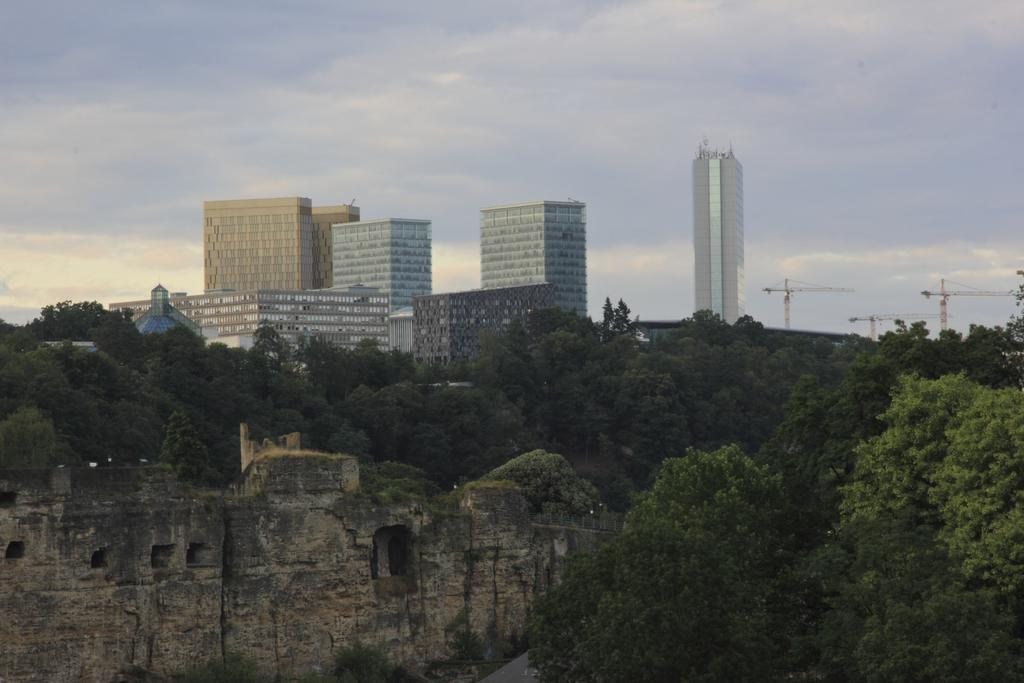What type of historical structure is in the image? There is a historical structure in the image, but the specific type is not mentioned in the facts. What surrounds the historical structure? There are trees around the historical structure. What can be seen in the background of the image? There are buildings and cranes in the background of the image. What is visible in the sky in the image? The sky is visible in the background of the image. What type of humor is being displayed by the horses in the image? There are no horses present in the image, so it is not possible to determine if any humor is being displayed. 